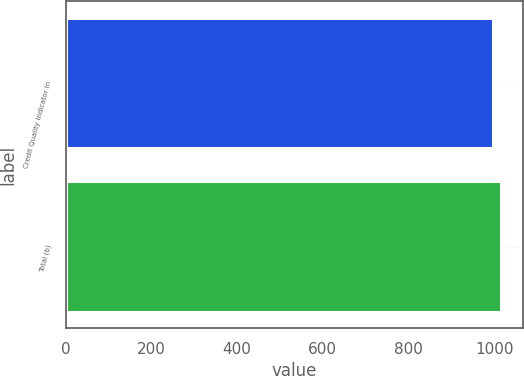Convert chart to OTSL. <chart><loc_0><loc_0><loc_500><loc_500><bar_chart><fcel>Credit Quality Indicator In<fcel>Total (b)<nl><fcel>998<fcel>1016<nl></chart> 